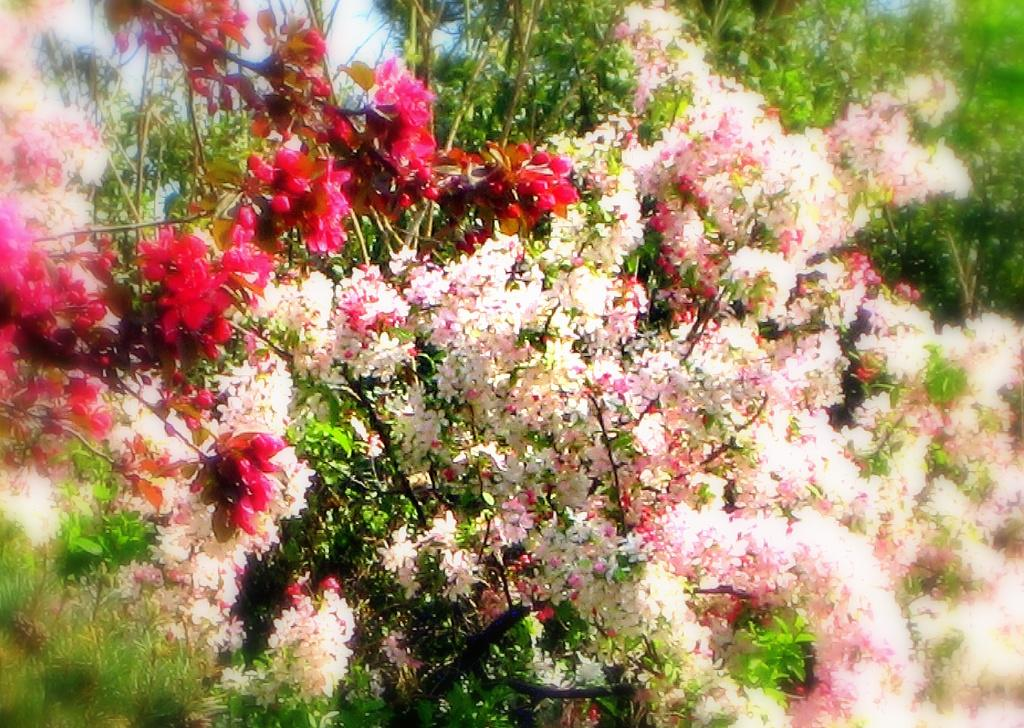What type of living organisms can be seen in the image? There are flowers in the image. Where are the flowers located? The flowers are present on plants. What is the quiet plot of land where the flowers are located in the image? There is no mention of a plot of land or its quietness in the image; it only features flowers on plants. 